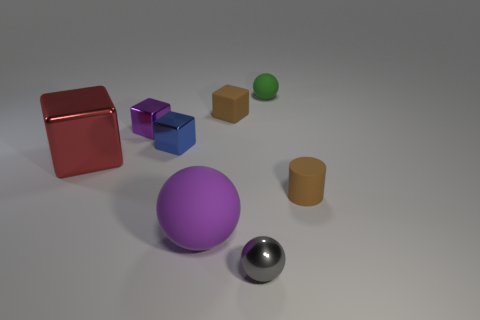Subtract all small rubber spheres. How many spheres are left? 2 Subtract all gray spheres. How many spheres are left? 2 Add 1 large red metal cubes. How many objects exist? 9 Subtract all cylinders. How many objects are left? 7 Subtract 0 red spheres. How many objects are left? 8 Subtract 1 cylinders. How many cylinders are left? 0 Subtract all gray spheres. Subtract all blue blocks. How many spheres are left? 2 Subtract all brown cylinders. How many purple spheres are left? 1 Subtract all red shiny things. Subtract all small matte cylinders. How many objects are left? 6 Add 6 big cubes. How many big cubes are left? 7 